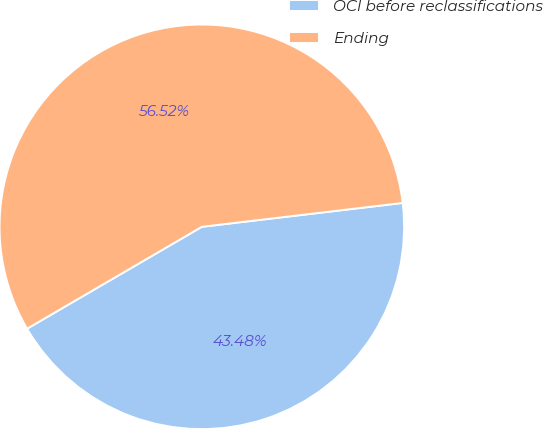Convert chart to OTSL. <chart><loc_0><loc_0><loc_500><loc_500><pie_chart><fcel>OCI before reclassifications<fcel>Ending<nl><fcel>43.48%<fcel>56.52%<nl></chart> 